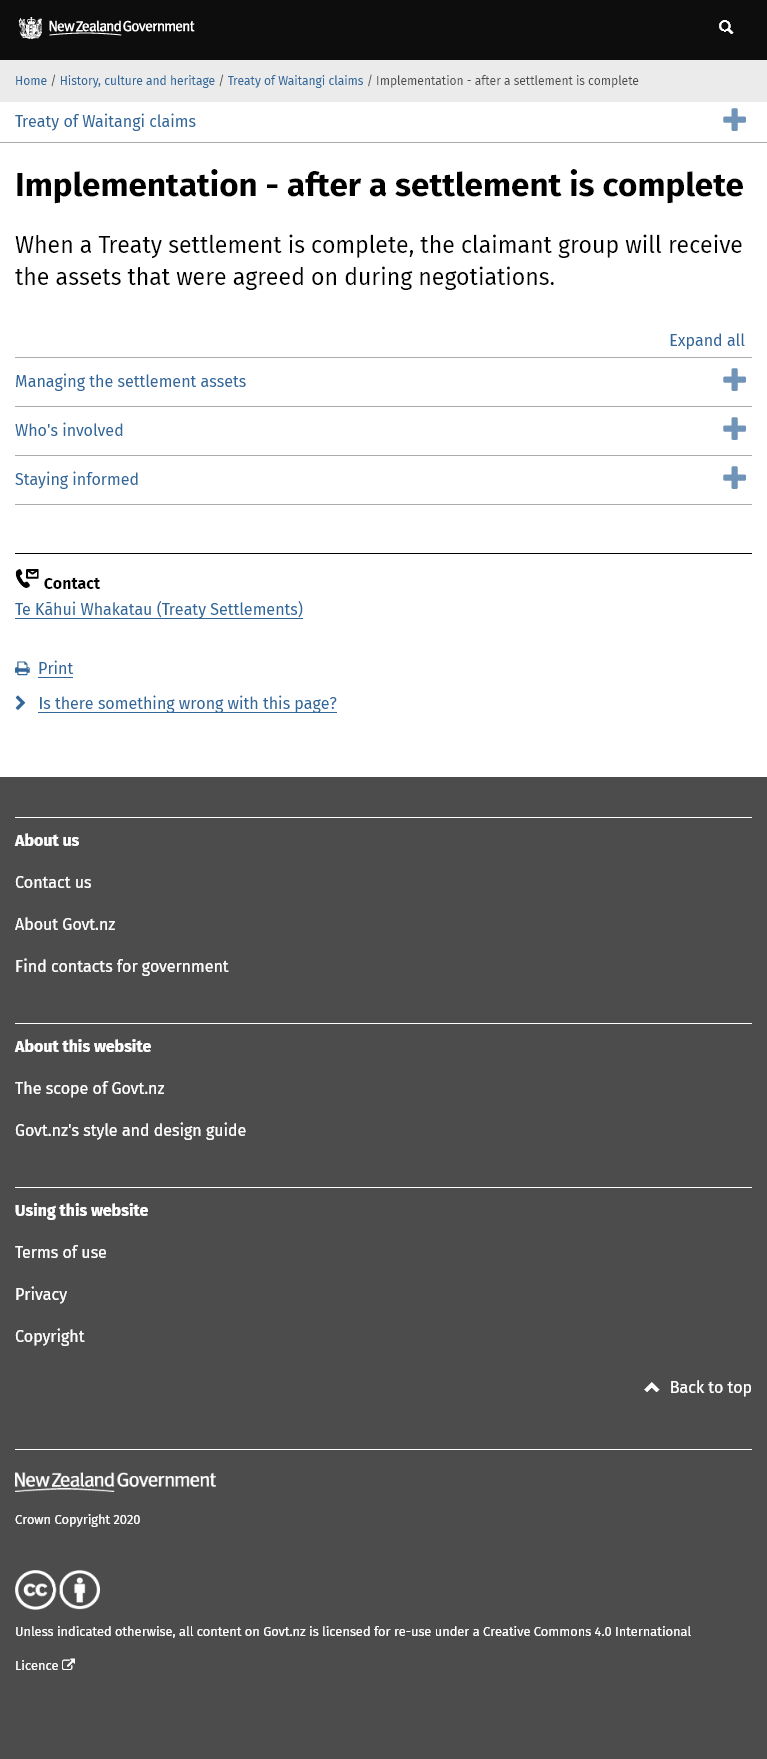Mention a couple of crucial points in this snapshot. The information about managing settlement assets and staying informed is included on this page. Assets are agreed upon during negotiations. The claimant group will receive the assets when a Treaty settlement is complete, as stated in the document. 